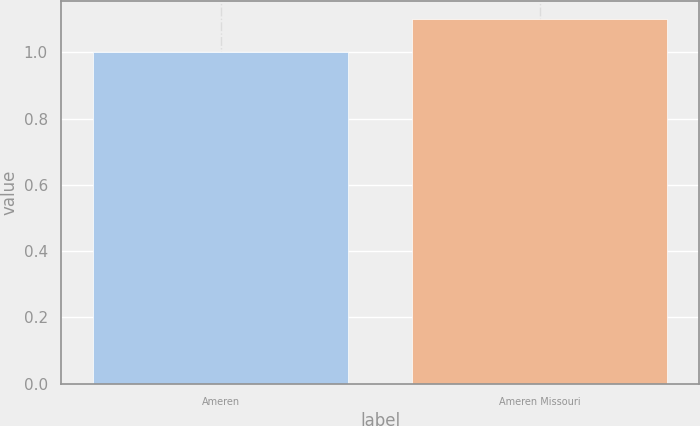<chart> <loc_0><loc_0><loc_500><loc_500><bar_chart><fcel>Ameren<fcel>Ameren Missouri<nl><fcel>1<fcel>1.1<nl></chart> 